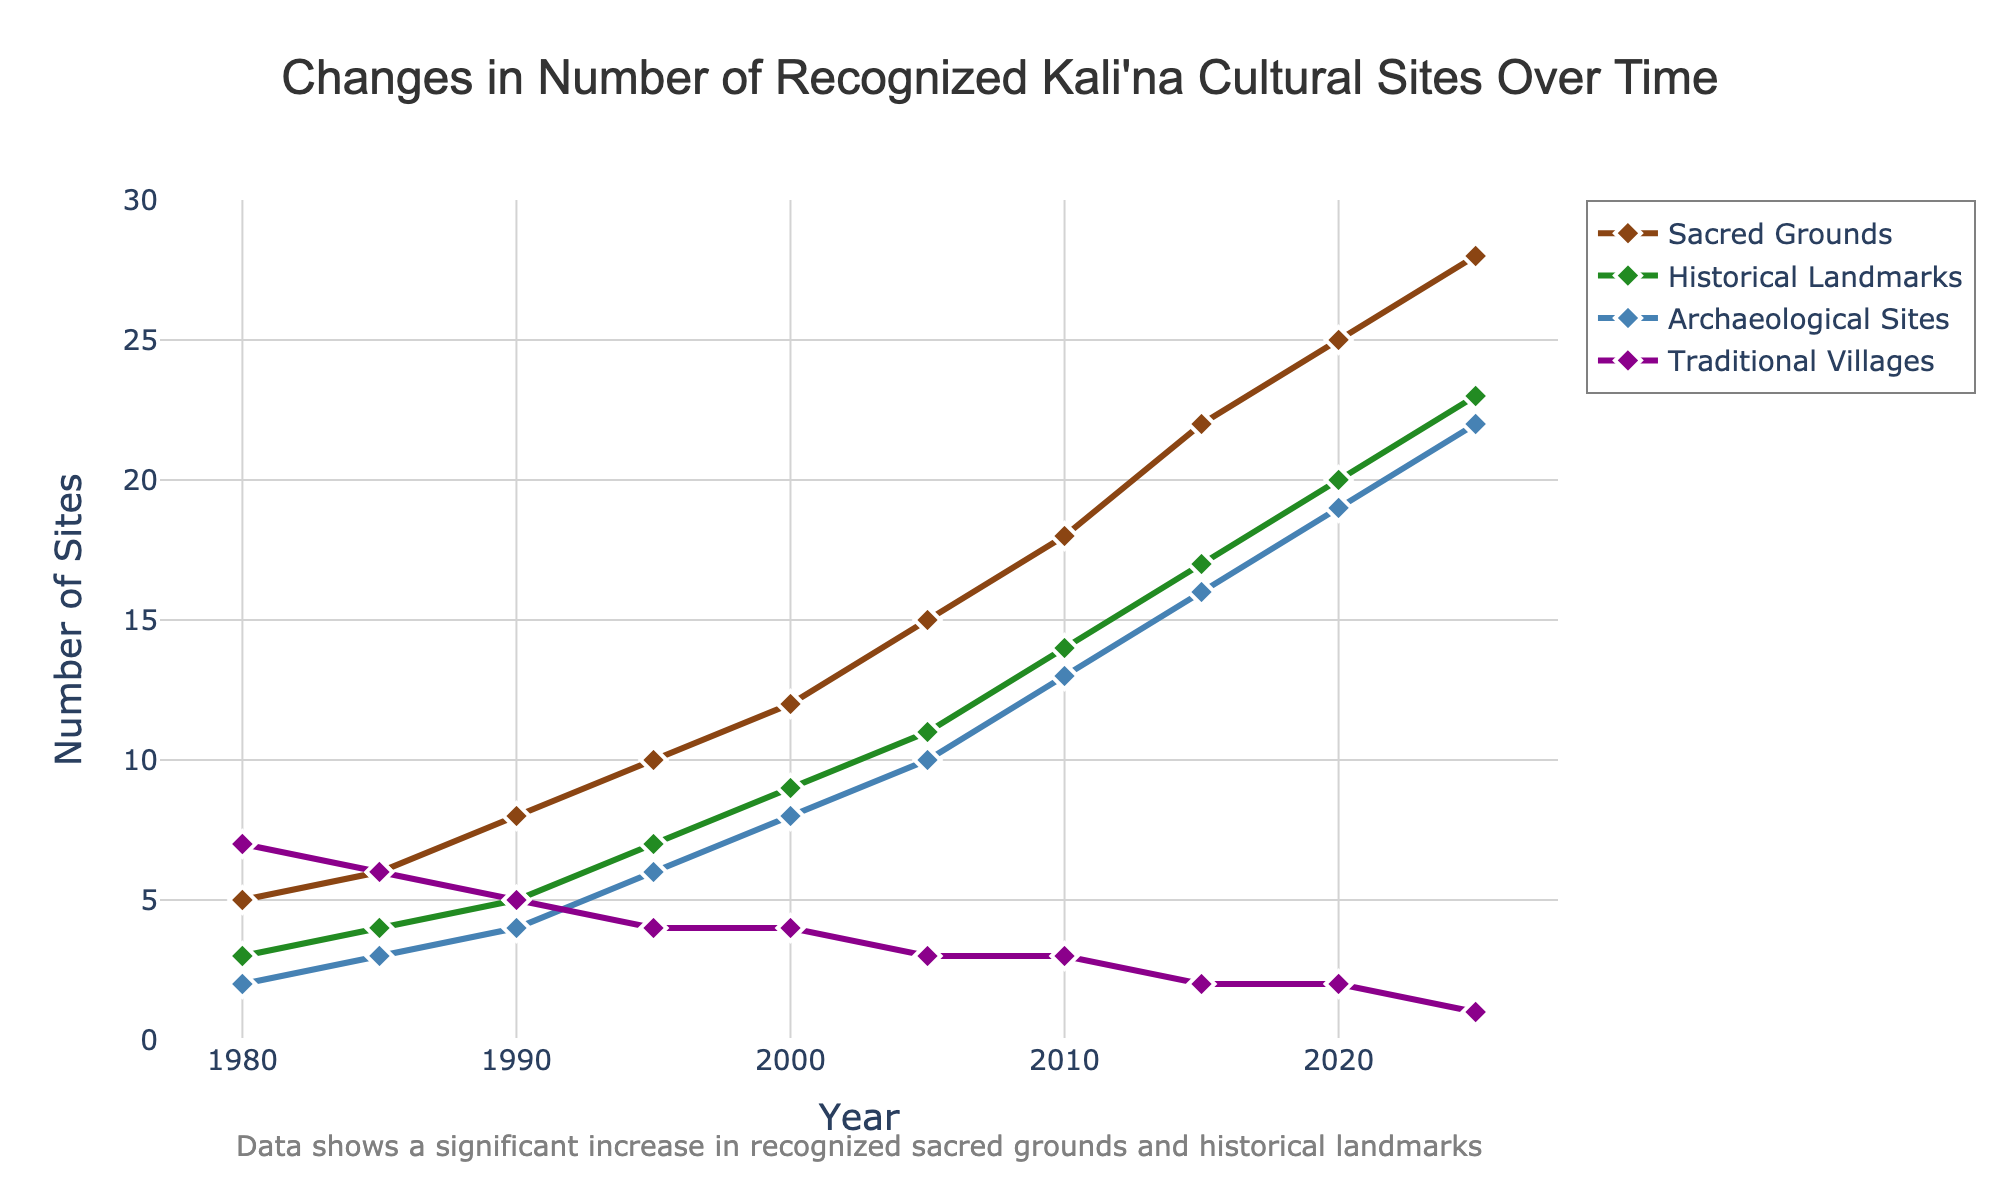What type of site shows the greatest increase in numbers from 1980 to 2025? To find the site type with the greatest increase, look at the differences for each site type between 1980 and 2025. Sacred Grounds increase by 23 (from 5 to 28), Historical Landmarks increase by 20 (from 3 to 23), Archaeological Sites increase by 20 (from 2 to 22), and Traditional Villages decrease by 6 (from 7 to 1). Therefore, Sacred Grounds have the greatest increase.
Answer: Sacred Grounds Between which two consecutive periods does the number of Historical Landmarks increase the most? Observe the increments in the number of Historical Landmarks for each time period. The largest increment occurs between 2010 and 2015, with an increase of 3 sites (from 14 to 17).
Answer: 2010 and 2015 What is the total number of recognized sites of all types in the year 2000? Sum the number of Sacred Grounds (12), Historical Landmarks (9), Archaeological Sites (8), and Traditional Villages (4) for the year 2000. The total is 12 + 9 + 8 + 4 = 33.
Answer: 33 Which site type has the fewest number of sites recognized in 2025, and how many are there? Examine the values for 2025. Traditional Villages have only 1 site recognized in 2025, which is the fewest among the categories.
Answer: Traditional Villages, 1 Do any of the site types show a decrease in the number of recognized sites over any time period? Analyze the trend lines for each site type. Traditional Villages show a decrease in recognized sites between the years 1990 and 2025 (from 7 to 1).
Answer: Yes, Traditional Villages How much did the number of Archaeological Sites increase from 1980 to 2010? Compare the number of Archaeological Sites in 1980 (2) and 2010 (13). The increase is 13 - 2 = 11.
Answer: 11 Which site type had a continuous increase over every recorded period? Sacred Grounds display a continuous increase in the number of recognized sites from 1980 to 2025 without any decrease or plateau.
Answer: Sacred Grounds What is the average number of Historical Landmarks recognized between 1980 and 2025? Sum the number of recognized Historical Landmarks over all years (3 + 4 + 5 + 7 + 9 + 11 + 14 + 17 + 20 + 23 = 113) and divide by the number of years (10). The average is 113 / 10 = 11.3.
Answer: 11.3 